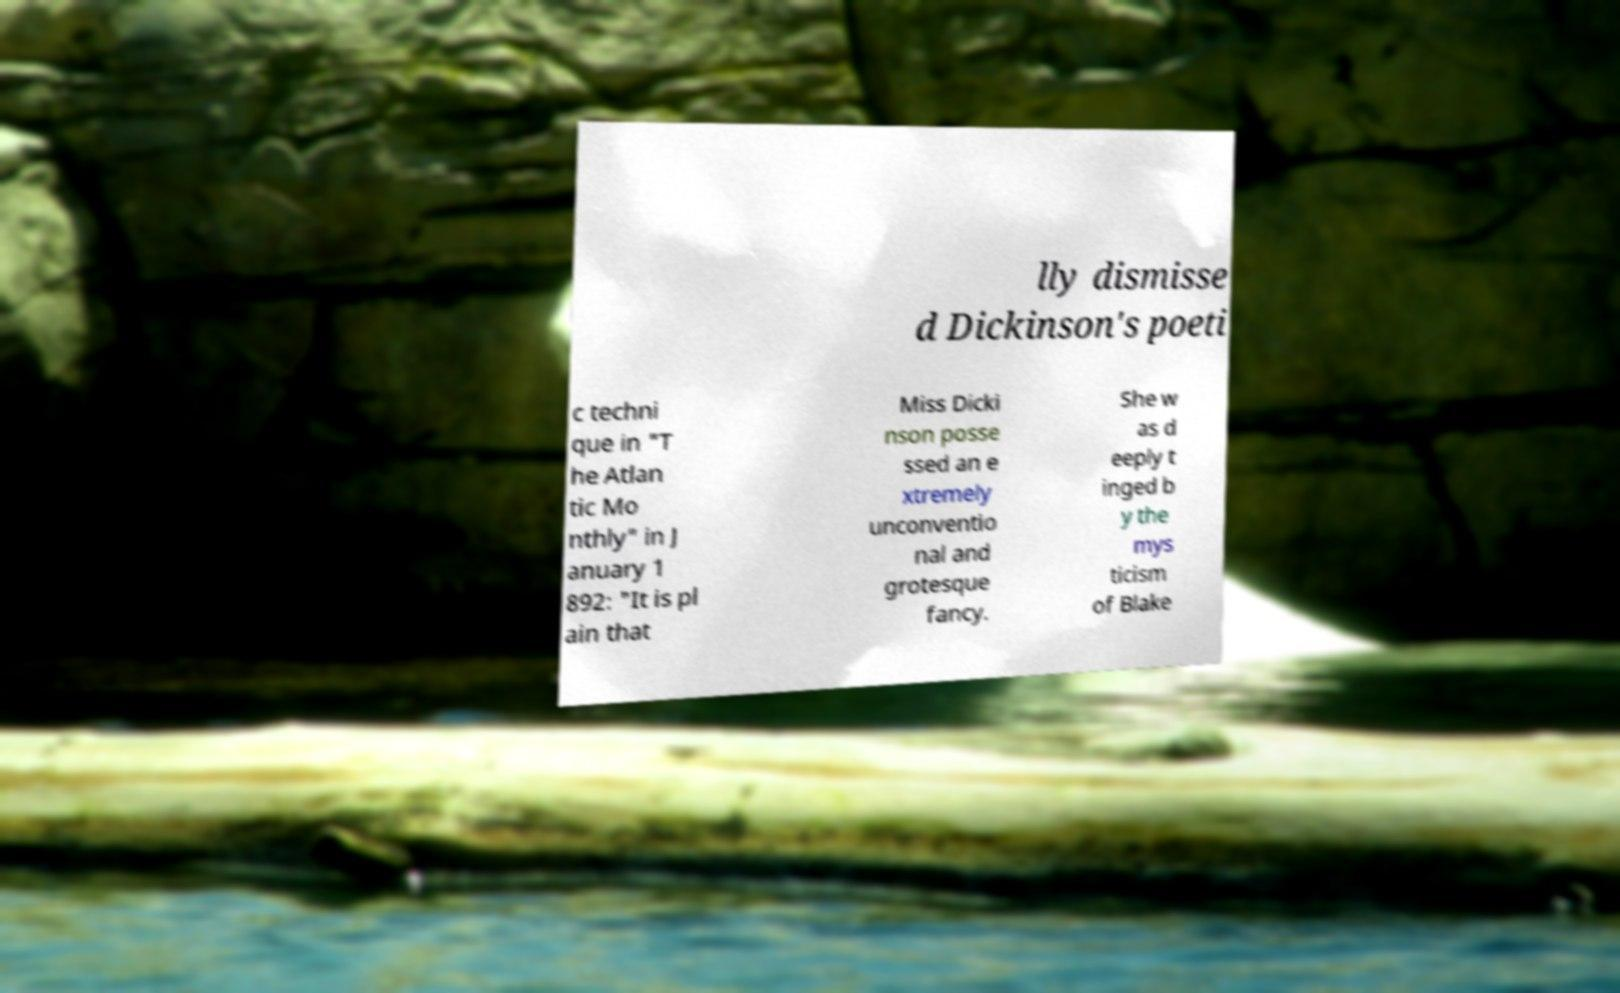Can you accurately transcribe the text from the provided image for me? lly dismisse d Dickinson's poeti c techni que in "T he Atlan tic Mo nthly" in J anuary 1 892: "It is pl ain that Miss Dicki nson posse ssed an e xtremely unconventio nal and grotesque fancy. She w as d eeply t inged b y the mys ticism of Blake 